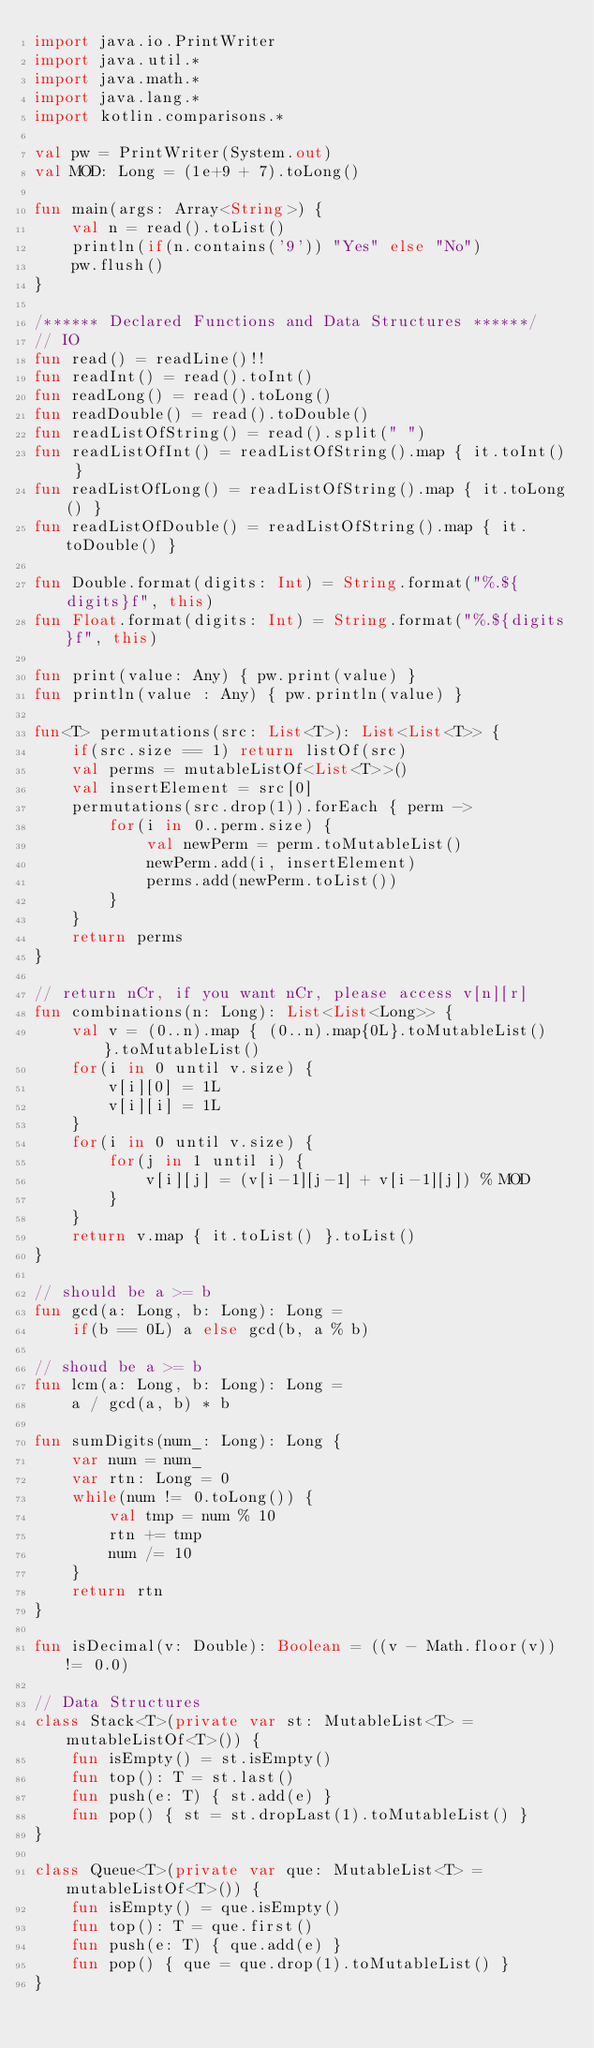<code> <loc_0><loc_0><loc_500><loc_500><_Kotlin_>import java.io.PrintWriter
import java.util.*
import java.math.*
import java.lang.*
import kotlin.comparisons.*

val pw = PrintWriter(System.out)
val MOD: Long = (1e+9 + 7).toLong()

fun main(args: Array<String>) {
    val n = read().toList()
    println(if(n.contains('9')) "Yes" else "No")
    pw.flush()
}

/****** Declared Functions and Data Structures ******/
// IO
fun read() = readLine()!!
fun readInt() = read().toInt()
fun readLong() = read().toLong()
fun readDouble() = read().toDouble()
fun readListOfString() = read().split(" ")
fun readListOfInt() = readListOfString().map { it.toInt() }
fun readListOfLong() = readListOfString().map { it.toLong() }
fun readListOfDouble() = readListOfString().map { it.toDouble() }

fun Double.format(digits: Int) = String.format("%.${digits}f", this)
fun Float.format(digits: Int) = String.format("%.${digits}f", this)

fun print(value: Any) { pw.print(value) }
fun println(value : Any) { pw.println(value) }

fun<T> permutations(src: List<T>): List<List<T>> {
    if(src.size == 1) return listOf(src)
    val perms = mutableListOf<List<T>>()
    val insertElement = src[0]
    permutations(src.drop(1)).forEach { perm ->
        for(i in 0..perm.size) {
            val newPerm = perm.toMutableList()
            newPerm.add(i, insertElement)
            perms.add(newPerm.toList())
        }
    }
    return perms
}

// return nCr, if you want nCr, please access v[n][r]
fun combinations(n: Long): List<List<Long>> {
    val v = (0..n).map { (0..n).map{0L}.toMutableList() }.toMutableList()
    for(i in 0 until v.size) {
        v[i][0] = 1L
        v[i][i] = 1L
    }
    for(i in 0 until v.size) {
        for(j in 1 until i) {
            v[i][j] = (v[i-1][j-1] + v[i-1][j]) % MOD
        }
    }
    return v.map { it.toList() }.toList()
}

// should be a >= b
fun gcd(a: Long, b: Long): Long = 
    if(b == 0L) a else gcd(b, a % b)

// shoud be a >= b
fun lcm(a: Long, b: Long): Long = 
    a / gcd(a, b) * b

fun sumDigits(num_: Long): Long {
    var num = num_
    var rtn: Long = 0
    while(num != 0.toLong()) {
        val tmp = num % 10
        rtn += tmp
        num /= 10
    }
    return rtn
}

fun isDecimal(v: Double): Boolean = ((v - Math.floor(v)) != 0.0)

// Data Structures
class Stack<T>(private var st: MutableList<T> = mutableListOf<T>()) {
    fun isEmpty() = st.isEmpty()
    fun top(): T = st.last()
    fun push(e: T) { st.add(e) }
    fun pop() { st = st.dropLast(1).toMutableList() }
}

class Queue<T>(private var que: MutableList<T> = mutableListOf<T>()) {
    fun isEmpty() = que.isEmpty()
    fun top(): T = que.first()
    fun push(e: T) { que.add(e) }
    fun pop() { que = que.drop(1).toMutableList() }
}
</code> 